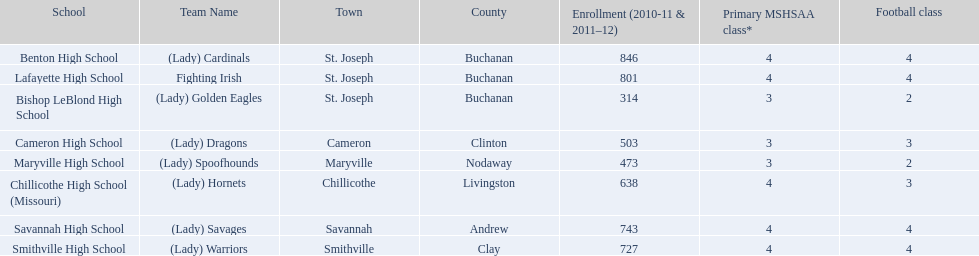Which schools are in the same town as bishop leblond? Benton High School, Lafayette High School. 